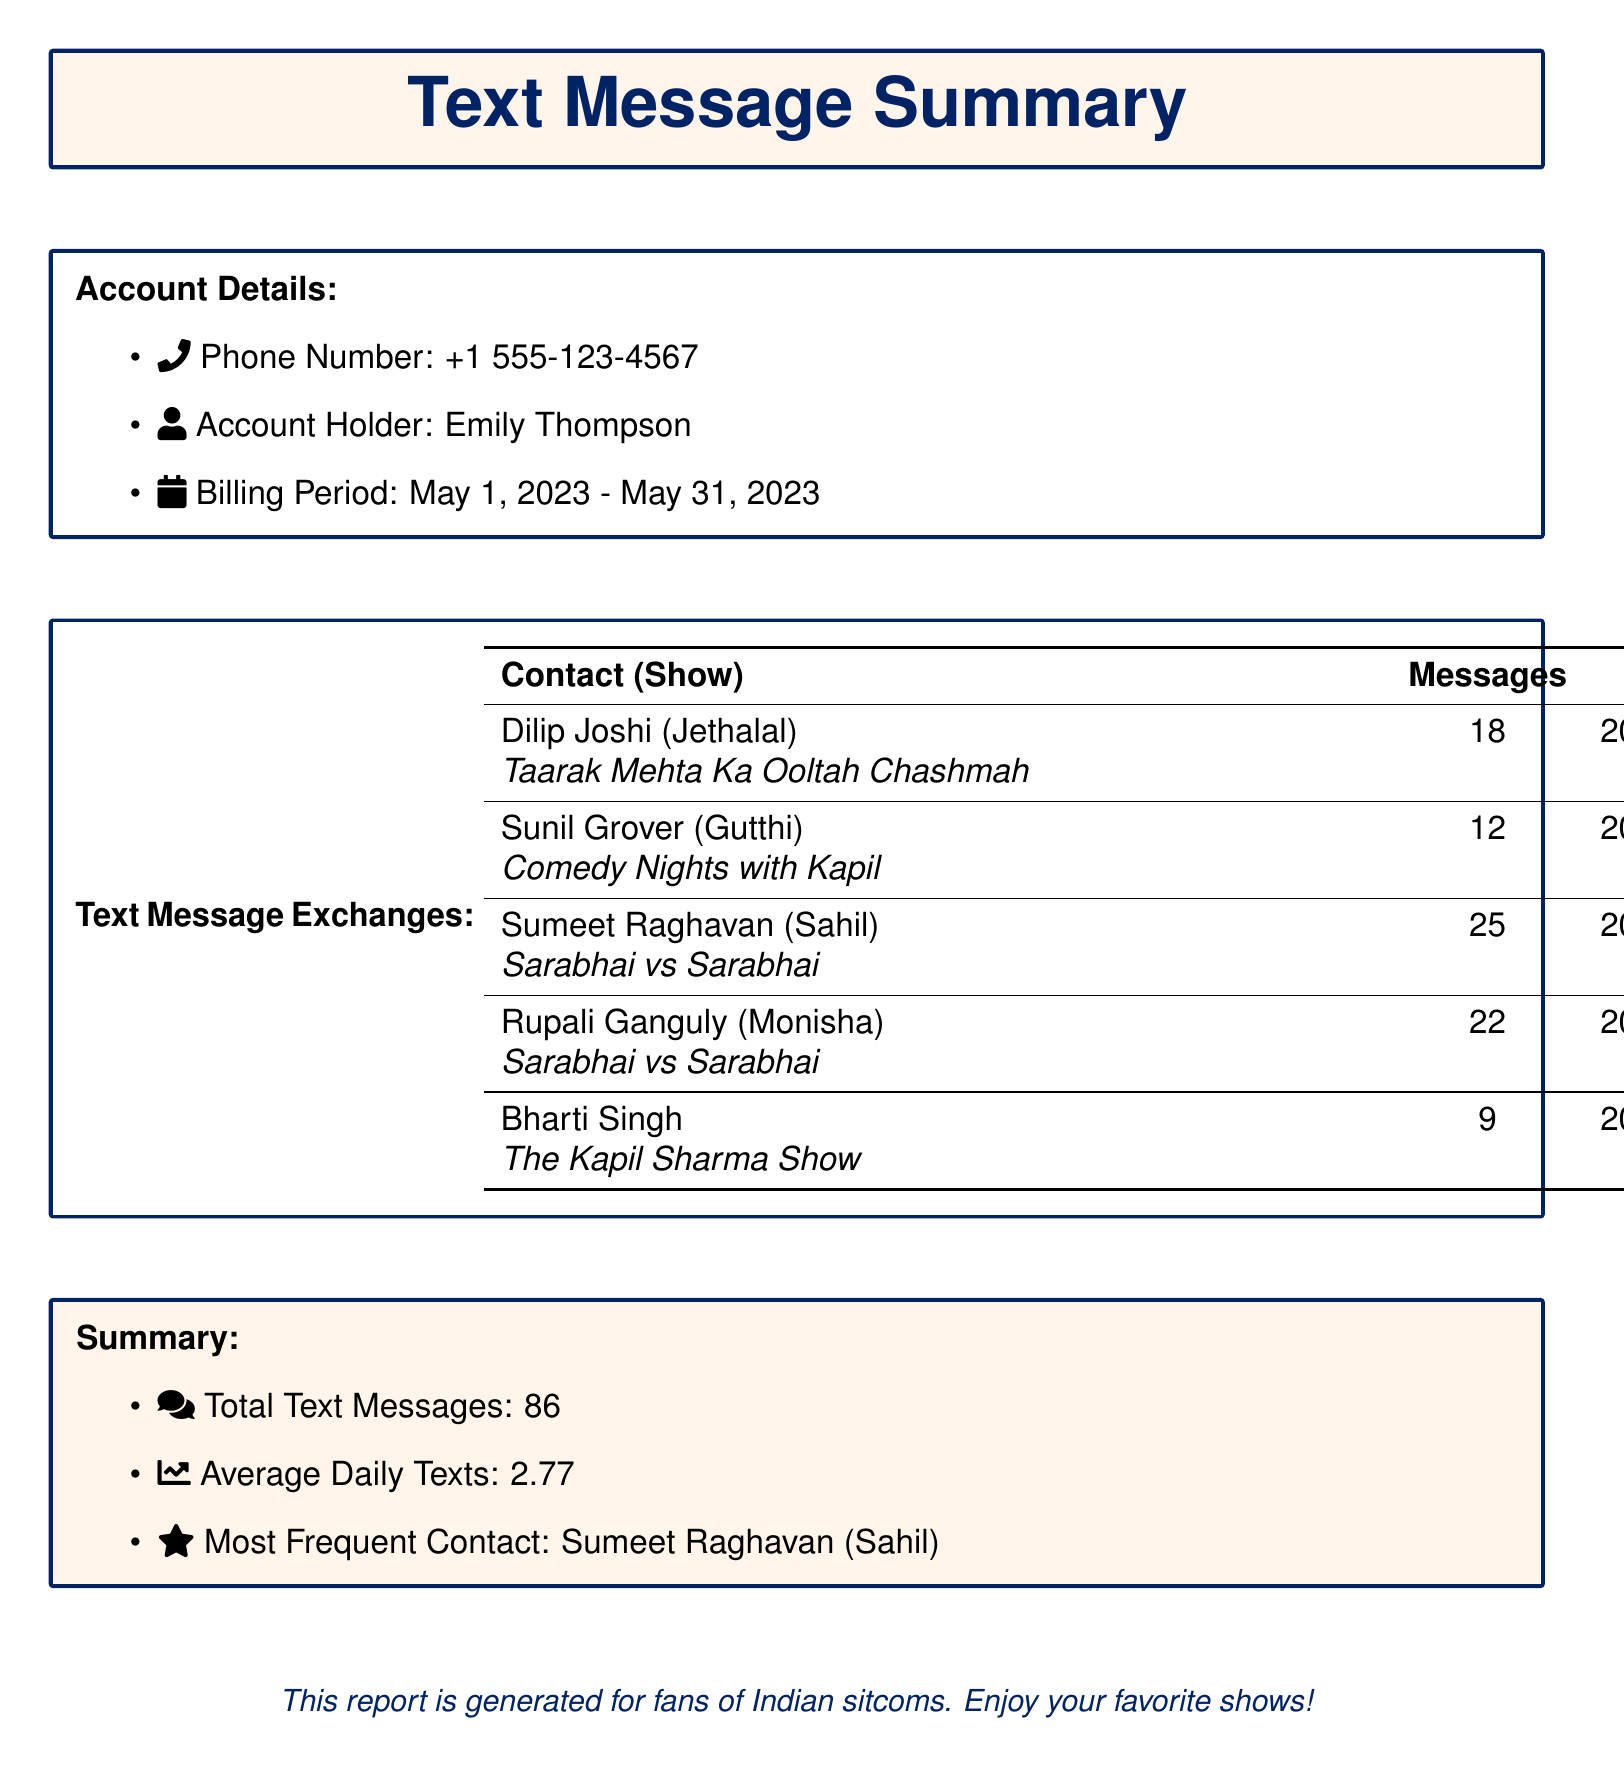What is the phone number? The phone number is listed under Account Details in the document.
Answer: +1 555-123-4567 Who is the most frequent contact? The most frequent contact is indicated in the Summary section of the document.
Answer: Sumeet Raghavan (Sahil) How many text messages were exchanged with Dilip Joshi? The number of text messages is specified in the Text Message Exchanges table.
Answer: 18 When was the last interaction with Rupali Ganguly? The last interaction date and time are provided in the Text Message Exchanges table.
Answer: 2023-05-29 16:55:42 What is the average daily number of texts? The average daily texts are summarized in the Summary section of the document.
Answer: 2.77 How many messages did Bharti Singh send? The message count for Bharti Singh can be found in the Text Message Exchanges table.
Answer: 9 What sitcom is Sumeet Raghavan from? The sitcom associated with Sumeet Raghavan is mentioned alongside his name in the Text Message Exchanges table.
Answer: Sarabhai vs Sarabhai What does the billing period cover? The billing period is specified in the Account Details section of the document.
Answer: May 1, 2023 - May 31, 2023 